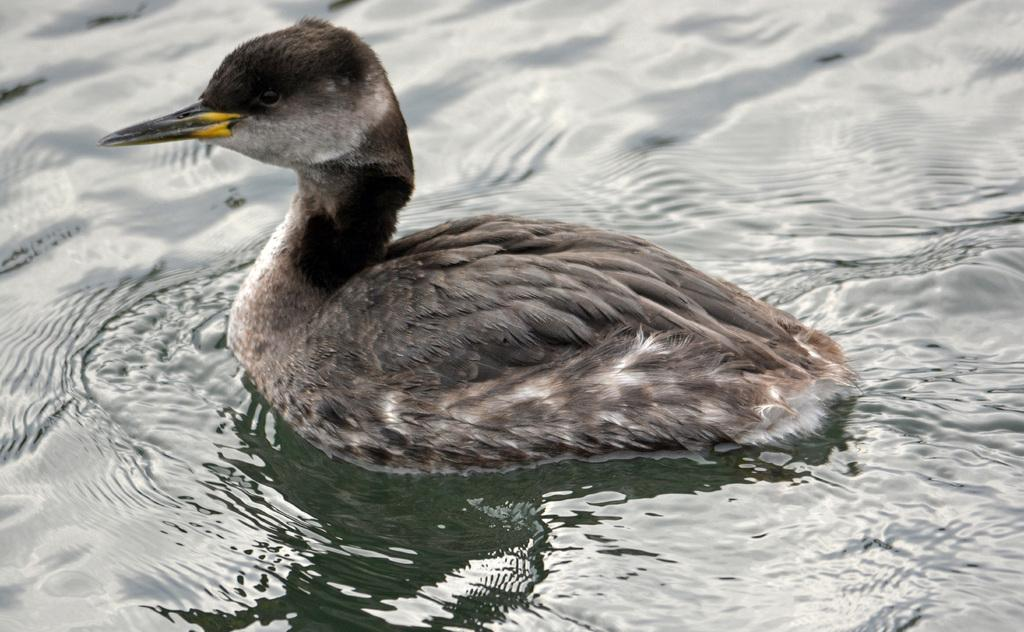What type of animal is in the image? There is a bird in the image. What color is the bird? The bird is brown in color. What can be seen in the background of the image? There is a water body in the background of the image. What type of toothbrush does the bird use in the image? There is no toothbrush present in the image, as birds do not use toothbrushes. 